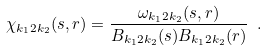<formula> <loc_0><loc_0><loc_500><loc_500>\chi _ { k _ { 1 } 2 k _ { 2 } } ( s , r ) = \frac { \omega _ { k _ { 1 } 2 k _ { 2 } } ( s , r ) } { B _ { k _ { 1 } 2 k _ { 2 } } ( s ) B _ { k _ { 1 } 2 k _ { 2 } } ( r ) } \ .</formula> 